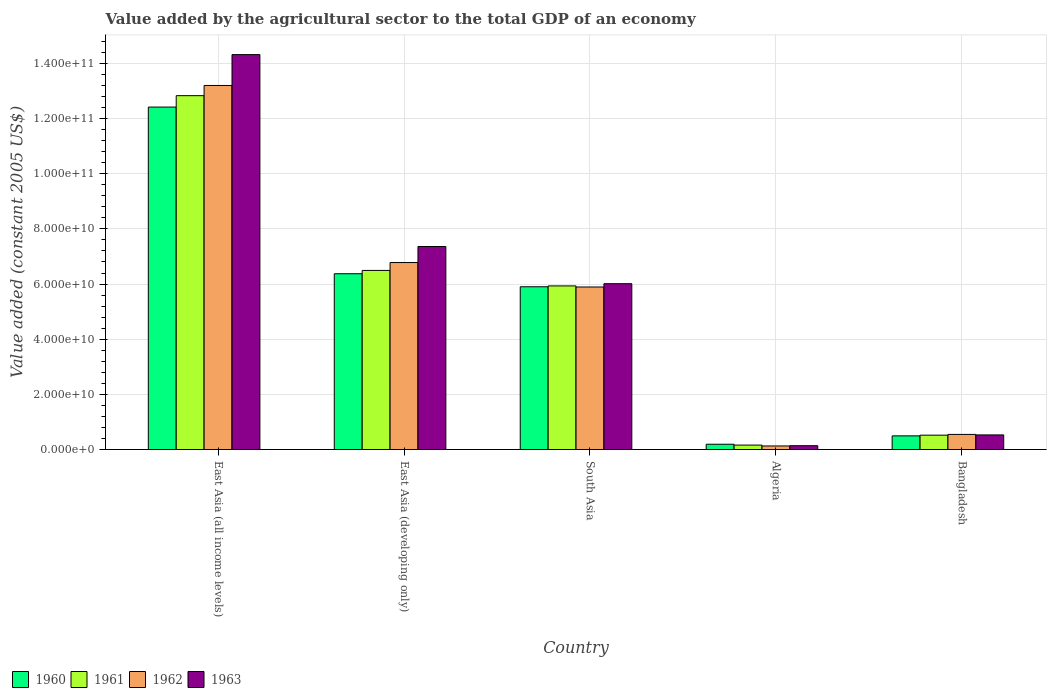How many different coloured bars are there?
Your answer should be very brief. 4. How many bars are there on the 2nd tick from the left?
Make the answer very short. 4. What is the label of the 1st group of bars from the left?
Provide a succinct answer. East Asia (all income levels). What is the value added by the agricultural sector in 1961 in South Asia?
Give a very brief answer. 5.93e+1. Across all countries, what is the maximum value added by the agricultural sector in 1961?
Ensure brevity in your answer.  1.28e+11. Across all countries, what is the minimum value added by the agricultural sector in 1962?
Ensure brevity in your answer.  1.29e+09. In which country was the value added by the agricultural sector in 1962 maximum?
Your answer should be very brief. East Asia (all income levels). In which country was the value added by the agricultural sector in 1960 minimum?
Your response must be concise. Algeria. What is the total value added by the agricultural sector in 1961 in the graph?
Offer a very short reply. 2.59e+11. What is the difference between the value added by the agricultural sector in 1960 in East Asia (developing only) and that in South Asia?
Make the answer very short. 4.72e+09. What is the difference between the value added by the agricultural sector in 1963 in Bangladesh and the value added by the agricultural sector in 1960 in East Asia (all income levels)?
Provide a succinct answer. -1.19e+11. What is the average value added by the agricultural sector in 1963 per country?
Offer a terse response. 5.67e+1. What is the difference between the value added by the agricultural sector of/in 1962 and value added by the agricultural sector of/in 1961 in South Asia?
Keep it short and to the point. -3.89e+08. What is the ratio of the value added by the agricultural sector in 1962 in Bangladesh to that in East Asia (developing only)?
Your answer should be compact. 0.08. What is the difference between the highest and the second highest value added by the agricultural sector in 1960?
Provide a short and direct response. 6.04e+1. What is the difference between the highest and the lowest value added by the agricultural sector in 1962?
Give a very brief answer. 1.31e+11. In how many countries, is the value added by the agricultural sector in 1962 greater than the average value added by the agricultural sector in 1962 taken over all countries?
Your answer should be very brief. 3. Is the sum of the value added by the agricultural sector in 1961 in East Asia (developing only) and South Asia greater than the maximum value added by the agricultural sector in 1963 across all countries?
Your answer should be compact. No. Does the graph contain any zero values?
Your answer should be compact. No. Where does the legend appear in the graph?
Provide a succinct answer. Bottom left. How many legend labels are there?
Your answer should be compact. 4. How are the legend labels stacked?
Your response must be concise. Horizontal. What is the title of the graph?
Keep it short and to the point. Value added by the agricultural sector to the total GDP of an economy. Does "1973" appear as one of the legend labels in the graph?
Provide a succinct answer. No. What is the label or title of the X-axis?
Give a very brief answer. Country. What is the label or title of the Y-axis?
Provide a succinct answer. Value added (constant 2005 US$). What is the Value added (constant 2005 US$) of 1960 in East Asia (all income levels)?
Ensure brevity in your answer.  1.24e+11. What is the Value added (constant 2005 US$) of 1961 in East Asia (all income levels)?
Ensure brevity in your answer.  1.28e+11. What is the Value added (constant 2005 US$) in 1962 in East Asia (all income levels)?
Your response must be concise. 1.32e+11. What is the Value added (constant 2005 US$) in 1963 in East Asia (all income levels)?
Offer a very short reply. 1.43e+11. What is the Value added (constant 2005 US$) of 1960 in East Asia (developing only)?
Offer a very short reply. 6.37e+1. What is the Value added (constant 2005 US$) of 1961 in East Asia (developing only)?
Ensure brevity in your answer.  6.49e+1. What is the Value added (constant 2005 US$) of 1962 in East Asia (developing only)?
Provide a short and direct response. 6.78e+1. What is the Value added (constant 2005 US$) in 1963 in East Asia (developing only)?
Offer a terse response. 7.36e+1. What is the Value added (constant 2005 US$) in 1960 in South Asia?
Provide a short and direct response. 5.90e+1. What is the Value added (constant 2005 US$) in 1961 in South Asia?
Your answer should be compact. 5.93e+1. What is the Value added (constant 2005 US$) of 1962 in South Asia?
Offer a very short reply. 5.89e+1. What is the Value added (constant 2005 US$) in 1963 in South Asia?
Offer a terse response. 6.01e+1. What is the Value added (constant 2005 US$) in 1960 in Algeria?
Ensure brevity in your answer.  1.92e+09. What is the Value added (constant 2005 US$) of 1961 in Algeria?
Offer a very short reply. 1.61e+09. What is the Value added (constant 2005 US$) in 1962 in Algeria?
Offer a very short reply. 1.29e+09. What is the Value added (constant 2005 US$) in 1963 in Algeria?
Make the answer very short. 1.39e+09. What is the Value added (constant 2005 US$) in 1960 in Bangladesh?
Provide a succinct answer. 4.95e+09. What is the Value added (constant 2005 US$) of 1961 in Bangladesh?
Keep it short and to the point. 5.21e+09. What is the Value added (constant 2005 US$) of 1962 in Bangladesh?
Your answer should be very brief. 5.48e+09. What is the Value added (constant 2005 US$) in 1963 in Bangladesh?
Provide a succinct answer. 5.30e+09. Across all countries, what is the maximum Value added (constant 2005 US$) of 1960?
Offer a very short reply. 1.24e+11. Across all countries, what is the maximum Value added (constant 2005 US$) in 1961?
Make the answer very short. 1.28e+11. Across all countries, what is the maximum Value added (constant 2005 US$) in 1962?
Ensure brevity in your answer.  1.32e+11. Across all countries, what is the maximum Value added (constant 2005 US$) in 1963?
Offer a very short reply. 1.43e+11. Across all countries, what is the minimum Value added (constant 2005 US$) of 1960?
Keep it short and to the point. 1.92e+09. Across all countries, what is the minimum Value added (constant 2005 US$) in 1961?
Provide a short and direct response. 1.61e+09. Across all countries, what is the minimum Value added (constant 2005 US$) in 1962?
Make the answer very short. 1.29e+09. Across all countries, what is the minimum Value added (constant 2005 US$) in 1963?
Your answer should be very brief. 1.39e+09. What is the total Value added (constant 2005 US$) of 1960 in the graph?
Offer a terse response. 2.54e+11. What is the total Value added (constant 2005 US$) of 1961 in the graph?
Offer a very short reply. 2.59e+11. What is the total Value added (constant 2005 US$) of 1962 in the graph?
Provide a succinct answer. 2.65e+11. What is the total Value added (constant 2005 US$) of 1963 in the graph?
Provide a short and direct response. 2.84e+11. What is the difference between the Value added (constant 2005 US$) of 1960 in East Asia (all income levels) and that in East Asia (developing only)?
Your answer should be compact. 6.04e+1. What is the difference between the Value added (constant 2005 US$) of 1961 in East Asia (all income levels) and that in East Asia (developing only)?
Make the answer very short. 6.34e+1. What is the difference between the Value added (constant 2005 US$) of 1962 in East Asia (all income levels) and that in East Asia (developing only)?
Provide a succinct answer. 6.42e+1. What is the difference between the Value added (constant 2005 US$) in 1963 in East Asia (all income levels) and that in East Asia (developing only)?
Keep it short and to the point. 6.96e+1. What is the difference between the Value added (constant 2005 US$) of 1960 in East Asia (all income levels) and that in South Asia?
Provide a succinct answer. 6.51e+1. What is the difference between the Value added (constant 2005 US$) in 1961 in East Asia (all income levels) and that in South Asia?
Your answer should be very brief. 6.90e+1. What is the difference between the Value added (constant 2005 US$) in 1962 in East Asia (all income levels) and that in South Asia?
Offer a terse response. 7.31e+1. What is the difference between the Value added (constant 2005 US$) of 1963 in East Asia (all income levels) and that in South Asia?
Offer a terse response. 8.31e+1. What is the difference between the Value added (constant 2005 US$) in 1960 in East Asia (all income levels) and that in Algeria?
Offer a terse response. 1.22e+11. What is the difference between the Value added (constant 2005 US$) of 1961 in East Asia (all income levels) and that in Algeria?
Your response must be concise. 1.27e+11. What is the difference between the Value added (constant 2005 US$) in 1962 in East Asia (all income levels) and that in Algeria?
Make the answer very short. 1.31e+11. What is the difference between the Value added (constant 2005 US$) in 1963 in East Asia (all income levels) and that in Algeria?
Make the answer very short. 1.42e+11. What is the difference between the Value added (constant 2005 US$) of 1960 in East Asia (all income levels) and that in Bangladesh?
Your response must be concise. 1.19e+11. What is the difference between the Value added (constant 2005 US$) of 1961 in East Asia (all income levels) and that in Bangladesh?
Your answer should be compact. 1.23e+11. What is the difference between the Value added (constant 2005 US$) in 1962 in East Asia (all income levels) and that in Bangladesh?
Offer a very short reply. 1.27e+11. What is the difference between the Value added (constant 2005 US$) of 1963 in East Asia (all income levels) and that in Bangladesh?
Keep it short and to the point. 1.38e+11. What is the difference between the Value added (constant 2005 US$) in 1960 in East Asia (developing only) and that in South Asia?
Keep it short and to the point. 4.72e+09. What is the difference between the Value added (constant 2005 US$) in 1961 in East Asia (developing only) and that in South Asia?
Your answer should be very brief. 5.62e+09. What is the difference between the Value added (constant 2005 US$) of 1962 in East Asia (developing only) and that in South Asia?
Give a very brief answer. 8.86e+09. What is the difference between the Value added (constant 2005 US$) of 1963 in East Asia (developing only) and that in South Asia?
Your answer should be very brief. 1.35e+1. What is the difference between the Value added (constant 2005 US$) in 1960 in East Asia (developing only) and that in Algeria?
Make the answer very short. 6.18e+1. What is the difference between the Value added (constant 2005 US$) of 1961 in East Asia (developing only) and that in Algeria?
Keep it short and to the point. 6.33e+1. What is the difference between the Value added (constant 2005 US$) of 1962 in East Asia (developing only) and that in Algeria?
Offer a terse response. 6.65e+1. What is the difference between the Value added (constant 2005 US$) of 1963 in East Asia (developing only) and that in Algeria?
Offer a very short reply. 7.22e+1. What is the difference between the Value added (constant 2005 US$) of 1960 in East Asia (developing only) and that in Bangladesh?
Provide a short and direct response. 5.88e+1. What is the difference between the Value added (constant 2005 US$) in 1961 in East Asia (developing only) and that in Bangladesh?
Offer a terse response. 5.97e+1. What is the difference between the Value added (constant 2005 US$) of 1962 in East Asia (developing only) and that in Bangladesh?
Offer a terse response. 6.23e+1. What is the difference between the Value added (constant 2005 US$) of 1963 in East Asia (developing only) and that in Bangladesh?
Keep it short and to the point. 6.83e+1. What is the difference between the Value added (constant 2005 US$) in 1960 in South Asia and that in Algeria?
Your response must be concise. 5.71e+1. What is the difference between the Value added (constant 2005 US$) in 1961 in South Asia and that in Algeria?
Ensure brevity in your answer.  5.77e+1. What is the difference between the Value added (constant 2005 US$) of 1962 in South Asia and that in Algeria?
Your response must be concise. 5.76e+1. What is the difference between the Value added (constant 2005 US$) in 1963 in South Asia and that in Algeria?
Provide a short and direct response. 5.87e+1. What is the difference between the Value added (constant 2005 US$) in 1960 in South Asia and that in Bangladesh?
Provide a short and direct response. 5.41e+1. What is the difference between the Value added (constant 2005 US$) of 1961 in South Asia and that in Bangladesh?
Your answer should be compact. 5.41e+1. What is the difference between the Value added (constant 2005 US$) of 1962 in South Asia and that in Bangladesh?
Provide a short and direct response. 5.35e+1. What is the difference between the Value added (constant 2005 US$) of 1963 in South Asia and that in Bangladesh?
Provide a short and direct response. 5.48e+1. What is the difference between the Value added (constant 2005 US$) of 1960 in Algeria and that in Bangladesh?
Ensure brevity in your answer.  -3.03e+09. What is the difference between the Value added (constant 2005 US$) of 1961 in Algeria and that in Bangladesh?
Offer a very short reply. -3.60e+09. What is the difference between the Value added (constant 2005 US$) of 1962 in Algeria and that in Bangladesh?
Provide a succinct answer. -4.19e+09. What is the difference between the Value added (constant 2005 US$) in 1963 in Algeria and that in Bangladesh?
Your answer should be very brief. -3.91e+09. What is the difference between the Value added (constant 2005 US$) of 1960 in East Asia (all income levels) and the Value added (constant 2005 US$) of 1961 in East Asia (developing only)?
Your answer should be very brief. 5.92e+1. What is the difference between the Value added (constant 2005 US$) of 1960 in East Asia (all income levels) and the Value added (constant 2005 US$) of 1962 in East Asia (developing only)?
Offer a very short reply. 5.64e+1. What is the difference between the Value added (constant 2005 US$) of 1960 in East Asia (all income levels) and the Value added (constant 2005 US$) of 1963 in East Asia (developing only)?
Your response must be concise. 5.06e+1. What is the difference between the Value added (constant 2005 US$) in 1961 in East Asia (all income levels) and the Value added (constant 2005 US$) in 1962 in East Asia (developing only)?
Keep it short and to the point. 6.05e+1. What is the difference between the Value added (constant 2005 US$) of 1961 in East Asia (all income levels) and the Value added (constant 2005 US$) of 1963 in East Asia (developing only)?
Provide a short and direct response. 5.47e+1. What is the difference between the Value added (constant 2005 US$) of 1962 in East Asia (all income levels) and the Value added (constant 2005 US$) of 1963 in East Asia (developing only)?
Provide a succinct answer. 5.84e+1. What is the difference between the Value added (constant 2005 US$) of 1960 in East Asia (all income levels) and the Value added (constant 2005 US$) of 1961 in South Asia?
Offer a very short reply. 6.48e+1. What is the difference between the Value added (constant 2005 US$) of 1960 in East Asia (all income levels) and the Value added (constant 2005 US$) of 1962 in South Asia?
Make the answer very short. 6.52e+1. What is the difference between the Value added (constant 2005 US$) of 1960 in East Asia (all income levels) and the Value added (constant 2005 US$) of 1963 in South Asia?
Your response must be concise. 6.40e+1. What is the difference between the Value added (constant 2005 US$) of 1961 in East Asia (all income levels) and the Value added (constant 2005 US$) of 1962 in South Asia?
Keep it short and to the point. 6.94e+1. What is the difference between the Value added (constant 2005 US$) of 1961 in East Asia (all income levels) and the Value added (constant 2005 US$) of 1963 in South Asia?
Give a very brief answer. 6.82e+1. What is the difference between the Value added (constant 2005 US$) in 1962 in East Asia (all income levels) and the Value added (constant 2005 US$) in 1963 in South Asia?
Your answer should be compact. 7.19e+1. What is the difference between the Value added (constant 2005 US$) of 1960 in East Asia (all income levels) and the Value added (constant 2005 US$) of 1961 in Algeria?
Your answer should be very brief. 1.23e+11. What is the difference between the Value added (constant 2005 US$) in 1960 in East Asia (all income levels) and the Value added (constant 2005 US$) in 1962 in Algeria?
Your answer should be compact. 1.23e+11. What is the difference between the Value added (constant 2005 US$) of 1960 in East Asia (all income levels) and the Value added (constant 2005 US$) of 1963 in Algeria?
Offer a terse response. 1.23e+11. What is the difference between the Value added (constant 2005 US$) of 1961 in East Asia (all income levels) and the Value added (constant 2005 US$) of 1962 in Algeria?
Your response must be concise. 1.27e+11. What is the difference between the Value added (constant 2005 US$) of 1961 in East Asia (all income levels) and the Value added (constant 2005 US$) of 1963 in Algeria?
Provide a succinct answer. 1.27e+11. What is the difference between the Value added (constant 2005 US$) of 1962 in East Asia (all income levels) and the Value added (constant 2005 US$) of 1963 in Algeria?
Your response must be concise. 1.31e+11. What is the difference between the Value added (constant 2005 US$) in 1960 in East Asia (all income levels) and the Value added (constant 2005 US$) in 1961 in Bangladesh?
Give a very brief answer. 1.19e+11. What is the difference between the Value added (constant 2005 US$) of 1960 in East Asia (all income levels) and the Value added (constant 2005 US$) of 1962 in Bangladesh?
Give a very brief answer. 1.19e+11. What is the difference between the Value added (constant 2005 US$) in 1960 in East Asia (all income levels) and the Value added (constant 2005 US$) in 1963 in Bangladesh?
Offer a terse response. 1.19e+11. What is the difference between the Value added (constant 2005 US$) in 1961 in East Asia (all income levels) and the Value added (constant 2005 US$) in 1962 in Bangladesh?
Your answer should be compact. 1.23e+11. What is the difference between the Value added (constant 2005 US$) of 1961 in East Asia (all income levels) and the Value added (constant 2005 US$) of 1963 in Bangladesh?
Offer a very short reply. 1.23e+11. What is the difference between the Value added (constant 2005 US$) of 1962 in East Asia (all income levels) and the Value added (constant 2005 US$) of 1963 in Bangladesh?
Your answer should be very brief. 1.27e+11. What is the difference between the Value added (constant 2005 US$) in 1960 in East Asia (developing only) and the Value added (constant 2005 US$) in 1961 in South Asia?
Make the answer very short. 4.42e+09. What is the difference between the Value added (constant 2005 US$) of 1960 in East Asia (developing only) and the Value added (constant 2005 US$) of 1962 in South Asia?
Your response must be concise. 4.81e+09. What is the difference between the Value added (constant 2005 US$) in 1960 in East Asia (developing only) and the Value added (constant 2005 US$) in 1963 in South Asia?
Your answer should be compact. 3.61e+09. What is the difference between the Value added (constant 2005 US$) in 1961 in East Asia (developing only) and the Value added (constant 2005 US$) in 1962 in South Asia?
Give a very brief answer. 6.00e+09. What is the difference between the Value added (constant 2005 US$) in 1961 in East Asia (developing only) and the Value added (constant 2005 US$) in 1963 in South Asia?
Your answer should be compact. 4.81e+09. What is the difference between the Value added (constant 2005 US$) of 1962 in East Asia (developing only) and the Value added (constant 2005 US$) of 1963 in South Asia?
Make the answer very short. 7.67e+09. What is the difference between the Value added (constant 2005 US$) of 1960 in East Asia (developing only) and the Value added (constant 2005 US$) of 1961 in Algeria?
Your answer should be compact. 6.21e+1. What is the difference between the Value added (constant 2005 US$) in 1960 in East Asia (developing only) and the Value added (constant 2005 US$) in 1962 in Algeria?
Offer a very short reply. 6.24e+1. What is the difference between the Value added (constant 2005 US$) of 1960 in East Asia (developing only) and the Value added (constant 2005 US$) of 1963 in Algeria?
Your response must be concise. 6.23e+1. What is the difference between the Value added (constant 2005 US$) of 1961 in East Asia (developing only) and the Value added (constant 2005 US$) of 1962 in Algeria?
Your answer should be very brief. 6.36e+1. What is the difference between the Value added (constant 2005 US$) of 1961 in East Asia (developing only) and the Value added (constant 2005 US$) of 1963 in Algeria?
Your answer should be compact. 6.35e+1. What is the difference between the Value added (constant 2005 US$) in 1962 in East Asia (developing only) and the Value added (constant 2005 US$) in 1963 in Algeria?
Offer a terse response. 6.64e+1. What is the difference between the Value added (constant 2005 US$) of 1960 in East Asia (developing only) and the Value added (constant 2005 US$) of 1961 in Bangladesh?
Your answer should be compact. 5.85e+1. What is the difference between the Value added (constant 2005 US$) in 1960 in East Asia (developing only) and the Value added (constant 2005 US$) in 1962 in Bangladesh?
Give a very brief answer. 5.83e+1. What is the difference between the Value added (constant 2005 US$) in 1960 in East Asia (developing only) and the Value added (constant 2005 US$) in 1963 in Bangladesh?
Offer a very short reply. 5.84e+1. What is the difference between the Value added (constant 2005 US$) in 1961 in East Asia (developing only) and the Value added (constant 2005 US$) in 1962 in Bangladesh?
Your answer should be compact. 5.95e+1. What is the difference between the Value added (constant 2005 US$) of 1961 in East Asia (developing only) and the Value added (constant 2005 US$) of 1963 in Bangladesh?
Keep it short and to the point. 5.96e+1. What is the difference between the Value added (constant 2005 US$) in 1962 in East Asia (developing only) and the Value added (constant 2005 US$) in 1963 in Bangladesh?
Your answer should be very brief. 6.25e+1. What is the difference between the Value added (constant 2005 US$) of 1960 in South Asia and the Value added (constant 2005 US$) of 1961 in Algeria?
Provide a succinct answer. 5.74e+1. What is the difference between the Value added (constant 2005 US$) of 1960 in South Asia and the Value added (constant 2005 US$) of 1962 in Algeria?
Make the answer very short. 5.77e+1. What is the difference between the Value added (constant 2005 US$) of 1960 in South Asia and the Value added (constant 2005 US$) of 1963 in Algeria?
Offer a terse response. 5.76e+1. What is the difference between the Value added (constant 2005 US$) of 1961 in South Asia and the Value added (constant 2005 US$) of 1962 in Algeria?
Make the answer very short. 5.80e+1. What is the difference between the Value added (constant 2005 US$) in 1961 in South Asia and the Value added (constant 2005 US$) in 1963 in Algeria?
Your response must be concise. 5.79e+1. What is the difference between the Value added (constant 2005 US$) of 1962 in South Asia and the Value added (constant 2005 US$) of 1963 in Algeria?
Provide a succinct answer. 5.75e+1. What is the difference between the Value added (constant 2005 US$) of 1960 in South Asia and the Value added (constant 2005 US$) of 1961 in Bangladesh?
Provide a short and direct response. 5.38e+1. What is the difference between the Value added (constant 2005 US$) of 1960 in South Asia and the Value added (constant 2005 US$) of 1962 in Bangladesh?
Your response must be concise. 5.35e+1. What is the difference between the Value added (constant 2005 US$) of 1960 in South Asia and the Value added (constant 2005 US$) of 1963 in Bangladesh?
Keep it short and to the point. 5.37e+1. What is the difference between the Value added (constant 2005 US$) in 1961 in South Asia and the Value added (constant 2005 US$) in 1962 in Bangladesh?
Provide a succinct answer. 5.38e+1. What is the difference between the Value added (constant 2005 US$) of 1961 in South Asia and the Value added (constant 2005 US$) of 1963 in Bangladesh?
Ensure brevity in your answer.  5.40e+1. What is the difference between the Value added (constant 2005 US$) of 1962 in South Asia and the Value added (constant 2005 US$) of 1963 in Bangladesh?
Ensure brevity in your answer.  5.36e+1. What is the difference between the Value added (constant 2005 US$) of 1960 in Algeria and the Value added (constant 2005 US$) of 1961 in Bangladesh?
Offer a very short reply. -3.29e+09. What is the difference between the Value added (constant 2005 US$) of 1960 in Algeria and the Value added (constant 2005 US$) of 1962 in Bangladesh?
Give a very brief answer. -3.56e+09. What is the difference between the Value added (constant 2005 US$) of 1960 in Algeria and the Value added (constant 2005 US$) of 1963 in Bangladesh?
Provide a succinct answer. -3.38e+09. What is the difference between the Value added (constant 2005 US$) in 1961 in Algeria and the Value added (constant 2005 US$) in 1962 in Bangladesh?
Your answer should be very brief. -3.87e+09. What is the difference between the Value added (constant 2005 US$) of 1961 in Algeria and the Value added (constant 2005 US$) of 1963 in Bangladesh?
Keep it short and to the point. -3.69e+09. What is the difference between the Value added (constant 2005 US$) of 1962 in Algeria and the Value added (constant 2005 US$) of 1963 in Bangladesh?
Your answer should be compact. -4.00e+09. What is the average Value added (constant 2005 US$) of 1960 per country?
Keep it short and to the point. 5.08e+1. What is the average Value added (constant 2005 US$) in 1961 per country?
Make the answer very short. 5.19e+1. What is the average Value added (constant 2005 US$) of 1962 per country?
Give a very brief answer. 5.31e+1. What is the average Value added (constant 2005 US$) in 1963 per country?
Offer a very short reply. 5.67e+1. What is the difference between the Value added (constant 2005 US$) of 1960 and Value added (constant 2005 US$) of 1961 in East Asia (all income levels)?
Give a very brief answer. -4.14e+09. What is the difference between the Value added (constant 2005 US$) in 1960 and Value added (constant 2005 US$) in 1962 in East Asia (all income levels)?
Provide a succinct answer. -7.83e+09. What is the difference between the Value added (constant 2005 US$) in 1960 and Value added (constant 2005 US$) in 1963 in East Asia (all income levels)?
Offer a very short reply. -1.90e+1. What is the difference between the Value added (constant 2005 US$) in 1961 and Value added (constant 2005 US$) in 1962 in East Asia (all income levels)?
Provide a succinct answer. -3.69e+09. What is the difference between the Value added (constant 2005 US$) in 1961 and Value added (constant 2005 US$) in 1963 in East Asia (all income levels)?
Your answer should be very brief. -1.49e+1. What is the difference between the Value added (constant 2005 US$) in 1962 and Value added (constant 2005 US$) in 1963 in East Asia (all income levels)?
Provide a short and direct response. -1.12e+1. What is the difference between the Value added (constant 2005 US$) of 1960 and Value added (constant 2005 US$) of 1961 in East Asia (developing only)?
Ensure brevity in your answer.  -1.20e+09. What is the difference between the Value added (constant 2005 US$) in 1960 and Value added (constant 2005 US$) in 1962 in East Asia (developing only)?
Provide a short and direct response. -4.06e+09. What is the difference between the Value added (constant 2005 US$) in 1960 and Value added (constant 2005 US$) in 1963 in East Asia (developing only)?
Offer a very short reply. -9.86e+09. What is the difference between the Value added (constant 2005 US$) in 1961 and Value added (constant 2005 US$) in 1962 in East Asia (developing only)?
Provide a succinct answer. -2.86e+09. What is the difference between the Value added (constant 2005 US$) of 1961 and Value added (constant 2005 US$) of 1963 in East Asia (developing only)?
Your response must be concise. -8.67e+09. What is the difference between the Value added (constant 2005 US$) in 1962 and Value added (constant 2005 US$) in 1963 in East Asia (developing only)?
Keep it short and to the point. -5.81e+09. What is the difference between the Value added (constant 2005 US$) of 1960 and Value added (constant 2005 US$) of 1961 in South Asia?
Your answer should be very brief. -3.02e+08. What is the difference between the Value added (constant 2005 US$) in 1960 and Value added (constant 2005 US$) in 1962 in South Asia?
Offer a very short reply. 8.71e+07. What is the difference between the Value added (constant 2005 US$) in 1960 and Value added (constant 2005 US$) in 1963 in South Asia?
Make the answer very short. -1.11e+09. What is the difference between the Value added (constant 2005 US$) of 1961 and Value added (constant 2005 US$) of 1962 in South Asia?
Give a very brief answer. 3.89e+08. What is the difference between the Value added (constant 2005 US$) in 1961 and Value added (constant 2005 US$) in 1963 in South Asia?
Provide a succinct answer. -8.04e+08. What is the difference between the Value added (constant 2005 US$) of 1962 and Value added (constant 2005 US$) of 1963 in South Asia?
Keep it short and to the point. -1.19e+09. What is the difference between the Value added (constant 2005 US$) in 1960 and Value added (constant 2005 US$) in 1961 in Algeria?
Provide a short and direct response. 3.07e+08. What is the difference between the Value added (constant 2005 US$) of 1960 and Value added (constant 2005 US$) of 1962 in Algeria?
Provide a short and direct response. 6.25e+08. What is the difference between the Value added (constant 2005 US$) of 1960 and Value added (constant 2005 US$) of 1963 in Algeria?
Provide a succinct answer. 5.27e+08. What is the difference between the Value added (constant 2005 US$) in 1961 and Value added (constant 2005 US$) in 1962 in Algeria?
Your answer should be very brief. 3.18e+08. What is the difference between the Value added (constant 2005 US$) in 1961 and Value added (constant 2005 US$) in 1963 in Algeria?
Give a very brief answer. 2.20e+08. What is the difference between the Value added (constant 2005 US$) in 1962 and Value added (constant 2005 US$) in 1963 in Algeria?
Make the answer very short. -9.79e+07. What is the difference between the Value added (constant 2005 US$) of 1960 and Value added (constant 2005 US$) of 1961 in Bangladesh?
Offer a very short reply. -2.58e+08. What is the difference between the Value added (constant 2005 US$) in 1960 and Value added (constant 2005 US$) in 1962 in Bangladesh?
Provide a short and direct response. -5.31e+08. What is the difference between the Value added (constant 2005 US$) of 1960 and Value added (constant 2005 US$) of 1963 in Bangladesh?
Your response must be concise. -3.47e+08. What is the difference between the Value added (constant 2005 US$) in 1961 and Value added (constant 2005 US$) in 1962 in Bangladesh?
Ensure brevity in your answer.  -2.73e+08. What is the difference between the Value added (constant 2005 US$) of 1961 and Value added (constant 2005 US$) of 1963 in Bangladesh?
Ensure brevity in your answer.  -8.88e+07. What is the difference between the Value added (constant 2005 US$) in 1962 and Value added (constant 2005 US$) in 1963 in Bangladesh?
Keep it short and to the point. 1.84e+08. What is the ratio of the Value added (constant 2005 US$) in 1960 in East Asia (all income levels) to that in East Asia (developing only)?
Give a very brief answer. 1.95. What is the ratio of the Value added (constant 2005 US$) in 1961 in East Asia (all income levels) to that in East Asia (developing only)?
Make the answer very short. 1.98. What is the ratio of the Value added (constant 2005 US$) of 1962 in East Asia (all income levels) to that in East Asia (developing only)?
Your response must be concise. 1.95. What is the ratio of the Value added (constant 2005 US$) of 1963 in East Asia (all income levels) to that in East Asia (developing only)?
Offer a terse response. 1.95. What is the ratio of the Value added (constant 2005 US$) of 1960 in East Asia (all income levels) to that in South Asia?
Provide a short and direct response. 2.1. What is the ratio of the Value added (constant 2005 US$) of 1961 in East Asia (all income levels) to that in South Asia?
Offer a terse response. 2.16. What is the ratio of the Value added (constant 2005 US$) in 1962 in East Asia (all income levels) to that in South Asia?
Offer a terse response. 2.24. What is the ratio of the Value added (constant 2005 US$) of 1963 in East Asia (all income levels) to that in South Asia?
Your response must be concise. 2.38. What is the ratio of the Value added (constant 2005 US$) in 1960 in East Asia (all income levels) to that in Algeria?
Provide a succinct answer. 64.83. What is the ratio of the Value added (constant 2005 US$) in 1961 in East Asia (all income levels) to that in Algeria?
Your answer should be compact. 79.77. What is the ratio of the Value added (constant 2005 US$) of 1962 in East Asia (all income levels) to that in Algeria?
Offer a terse response. 102.31. What is the ratio of the Value added (constant 2005 US$) in 1963 in East Asia (all income levels) to that in Algeria?
Your response must be concise. 103.15. What is the ratio of the Value added (constant 2005 US$) of 1960 in East Asia (all income levels) to that in Bangladesh?
Give a very brief answer. 25.09. What is the ratio of the Value added (constant 2005 US$) in 1961 in East Asia (all income levels) to that in Bangladesh?
Keep it short and to the point. 24.64. What is the ratio of the Value added (constant 2005 US$) of 1962 in East Asia (all income levels) to that in Bangladesh?
Provide a short and direct response. 24.09. What is the ratio of the Value added (constant 2005 US$) of 1963 in East Asia (all income levels) to that in Bangladesh?
Offer a very short reply. 27.04. What is the ratio of the Value added (constant 2005 US$) in 1961 in East Asia (developing only) to that in South Asia?
Offer a terse response. 1.09. What is the ratio of the Value added (constant 2005 US$) in 1962 in East Asia (developing only) to that in South Asia?
Your answer should be very brief. 1.15. What is the ratio of the Value added (constant 2005 US$) in 1963 in East Asia (developing only) to that in South Asia?
Ensure brevity in your answer.  1.22. What is the ratio of the Value added (constant 2005 US$) in 1960 in East Asia (developing only) to that in Algeria?
Offer a very short reply. 33.28. What is the ratio of the Value added (constant 2005 US$) of 1961 in East Asia (developing only) to that in Algeria?
Your answer should be very brief. 40.37. What is the ratio of the Value added (constant 2005 US$) of 1962 in East Asia (developing only) to that in Algeria?
Offer a terse response. 52.55. What is the ratio of the Value added (constant 2005 US$) in 1963 in East Asia (developing only) to that in Algeria?
Provide a succinct answer. 53.02. What is the ratio of the Value added (constant 2005 US$) in 1960 in East Asia (developing only) to that in Bangladesh?
Provide a short and direct response. 12.88. What is the ratio of the Value added (constant 2005 US$) of 1961 in East Asia (developing only) to that in Bangladesh?
Provide a succinct answer. 12.47. What is the ratio of the Value added (constant 2005 US$) in 1962 in East Asia (developing only) to that in Bangladesh?
Provide a succinct answer. 12.37. What is the ratio of the Value added (constant 2005 US$) of 1963 in East Asia (developing only) to that in Bangladesh?
Make the answer very short. 13.9. What is the ratio of the Value added (constant 2005 US$) in 1960 in South Asia to that in Algeria?
Provide a short and direct response. 30.81. What is the ratio of the Value added (constant 2005 US$) in 1961 in South Asia to that in Algeria?
Provide a short and direct response. 36.88. What is the ratio of the Value added (constant 2005 US$) of 1962 in South Asia to that in Algeria?
Give a very brief answer. 45.68. What is the ratio of the Value added (constant 2005 US$) in 1963 in South Asia to that in Algeria?
Ensure brevity in your answer.  43.31. What is the ratio of the Value added (constant 2005 US$) of 1960 in South Asia to that in Bangladesh?
Your response must be concise. 11.93. What is the ratio of the Value added (constant 2005 US$) in 1961 in South Asia to that in Bangladesh?
Provide a short and direct response. 11.39. What is the ratio of the Value added (constant 2005 US$) in 1962 in South Asia to that in Bangladesh?
Keep it short and to the point. 10.75. What is the ratio of the Value added (constant 2005 US$) of 1963 in South Asia to that in Bangladesh?
Make the answer very short. 11.35. What is the ratio of the Value added (constant 2005 US$) of 1960 in Algeria to that in Bangladesh?
Give a very brief answer. 0.39. What is the ratio of the Value added (constant 2005 US$) of 1961 in Algeria to that in Bangladesh?
Provide a succinct answer. 0.31. What is the ratio of the Value added (constant 2005 US$) in 1962 in Algeria to that in Bangladesh?
Give a very brief answer. 0.24. What is the ratio of the Value added (constant 2005 US$) in 1963 in Algeria to that in Bangladesh?
Give a very brief answer. 0.26. What is the difference between the highest and the second highest Value added (constant 2005 US$) in 1960?
Keep it short and to the point. 6.04e+1. What is the difference between the highest and the second highest Value added (constant 2005 US$) of 1961?
Offer a very short reply. 6.34e+1. What is the difference between the highest and the second highest Value added (constant 2005 US$) of 1962?
Your response must be concise. 6.42e+1. What is the difference between the highest and the second highest Value added (constant 2005 US$) of 1963?
Keep it short and to the point. 6.96e+1. What is the difference between the highest and the lowest Value added (constant 2005 US$) of 1960?
Your answer should be very brief. 1.22e+11. What is the difference between the highest and the lowest Value added (constant 2005 US$) in 1961?
Your answer should be very brief. 1.27e+11. What is the difference between the highest and the lowest Value added (constant 2005 US$) in 1962?
Give a very brief answer. 1.31e+11. What is the difference between the highest and the lowest Value added (constant 2005 US$) in 1963?
Give a very brief answer. 1.42e+11. 